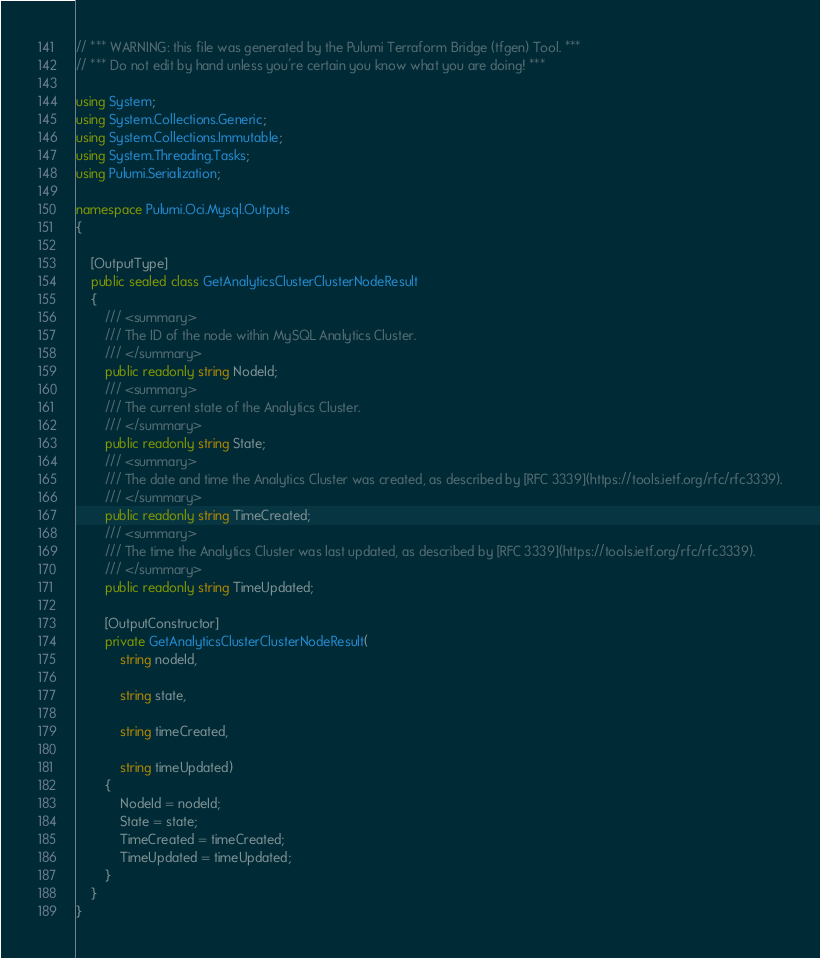<code> <loc_0><loc_0><loc_500><loc_500><_C#_>// *** WARNING: this file was generated by the Pulumi Terraform Bridge (tfgen) Tool. ***
// *** Do not edit by hand unless you're certain you know what you are doing! ***

using System;
using System.Collections.Generic;
using System.Collections.Immutable;
using System.Threading.Tasks;
using Pulumi.Serialization;

namespace Pulumi.Oci.Mysql.Outputs
{

    [OutputType]
    public sealed class GetAnalyticsClusterClusterNodeResult
    {
        /// <summary>
        /// The ID of the node within MySQL Analytics Cluster.
        /// </summary>
        public readonly string NodeId;
        /// <summary>
        /// The current state of the Analytics Cluster.
        /// </summary>
        public readonly string State;
        /// <summary>
        /// The date and time the Analytics Cluster was created, as described by [RFC 3339](https://tools.ietf.org/rfc/rfc3339).
        /// </summary>
        public readonly string TimeCreated;
        /// <summary>
        /// The time the Analytics Cluster was last updated, as described by [RFC 3339](https://tools.ietf.org/rfc/rfc3339).
        /// </summary>
        public readonly string TimeUpdated;

        [OutputConstructor]
        private GetAnalyticsClusterClusterNodeResult(
            string nodeId,

            string state,

            string timeCreated,

            string timeUpdated)
        {
            NodeId = nodeId;
            State = state;
            TimeCreated = timeCreated;
            TimeUpdated = timeUpdated;
        }
    }
}
</code> 